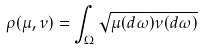Convert formula to latex. <formula><loc_0><loc_0><loc_500><loc_500>\rho ( \mu , \nu ) = \int _ { \Omega } \sqrt { \mu ( d \omega ) \nu ( d \omega ) }</formula> 